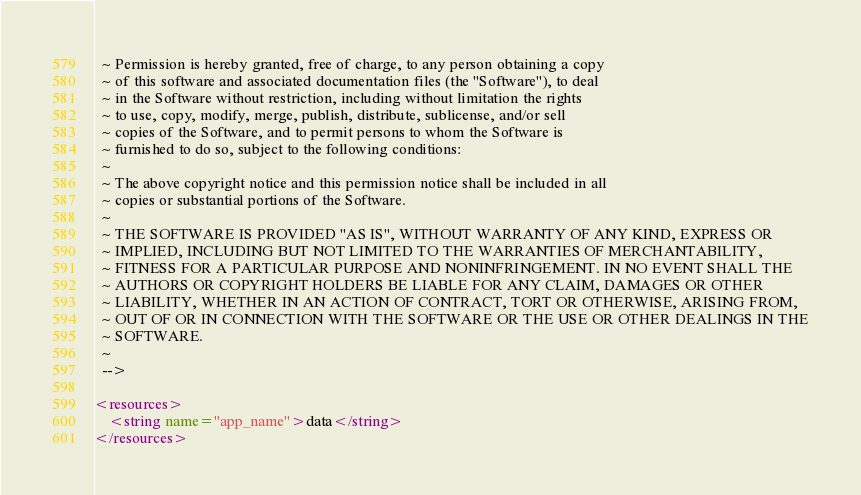Convert code to text. <code><loc_0><loc_0><loc_500><loc_500><_XML_>  ~ Permission is hereby granted, free of charge, to any person obtaining a copy
  ~ of this software and associated documentation files (the "Software"), to deal
  ~ in the Software without restriction, including without limitation the rights
  ~ to use, copy, modify, merge, publish, distribute, sublicense, and/or sell
  ~ copies of the Software, and to permit persons to whom the Software is
  ~ furnished to do so, subject to the following conditions:
  ~
  ~ The above copyright notice and this permission notice shall be included in all
  ~ copies or substantial portions of the Software.
  ~
  ~ THE SOFTWARE IS PROVIDED "AS IS", WITHOUT WARRANTY OF ANY KIND, EXPRESS OR
  ~ IMPLIED, INCLUDING BUT NOT LIMITED TO THE WARRANTIES OF MERCHANTABILITY,
  ~ FITNESS FOR A PARTICULAR PURPOSE AND NONINFRINGEMENT. IN NO EVENT SHALL THE
  ~ AUTHORS OR COPYRIGHT HOLDERS BE LIABLE FOR ANY CLAIM, DAMAGES OR OTHER
  ~ LIABILITY, WHETHER IN AN ACTION OF CONTRACT, TORT OR OTHERWISE, ARISING FROM,
  ~ OUT OF OR IN CONNECTION WITH THE SOFTWARE OR THE USE OR OTHER DEALINGS IN THE
  ~ SOFTWARE.
  ~
  -->

<resources>
    <string name="app_name">data</string>
</resources>
</code> 